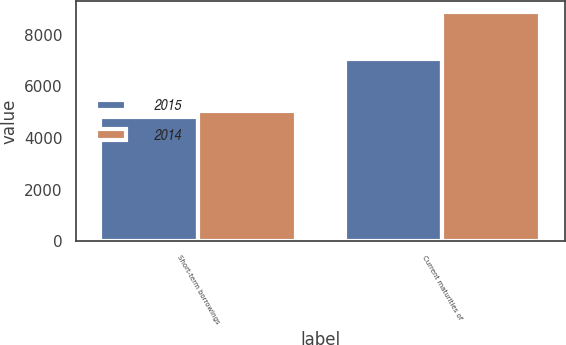Convert chart to OTSL. <chart><loc_0><loc_0><loc_500><loc_500><stacked_bar_chart><ecel><fcel>Short-term borrowings<fcel>Current maturities of<nl><fcel>2015<fcel>4829<fcel>7067<nl><fcel>2014<fcel>5056<fcel>8876<nl></chart> 